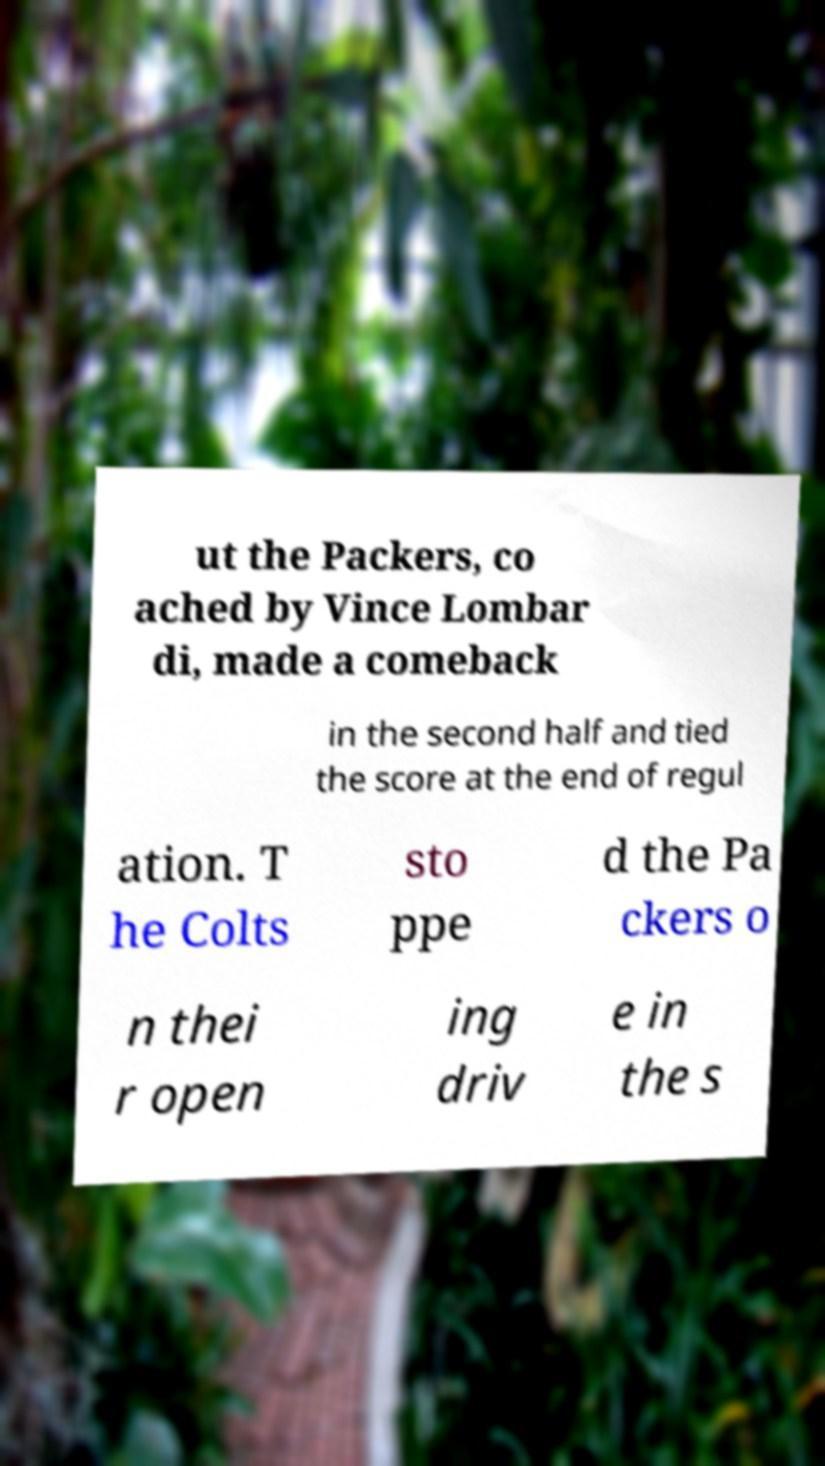Please identify and transcribe the text found in this image. ut the Packers, co ached by Vince Lombar di, made a comeback in the second half and tied the score at the end of regul ation. T he Colts sto ppe d the Pa ckers o n thei r open ing driv e in the s 